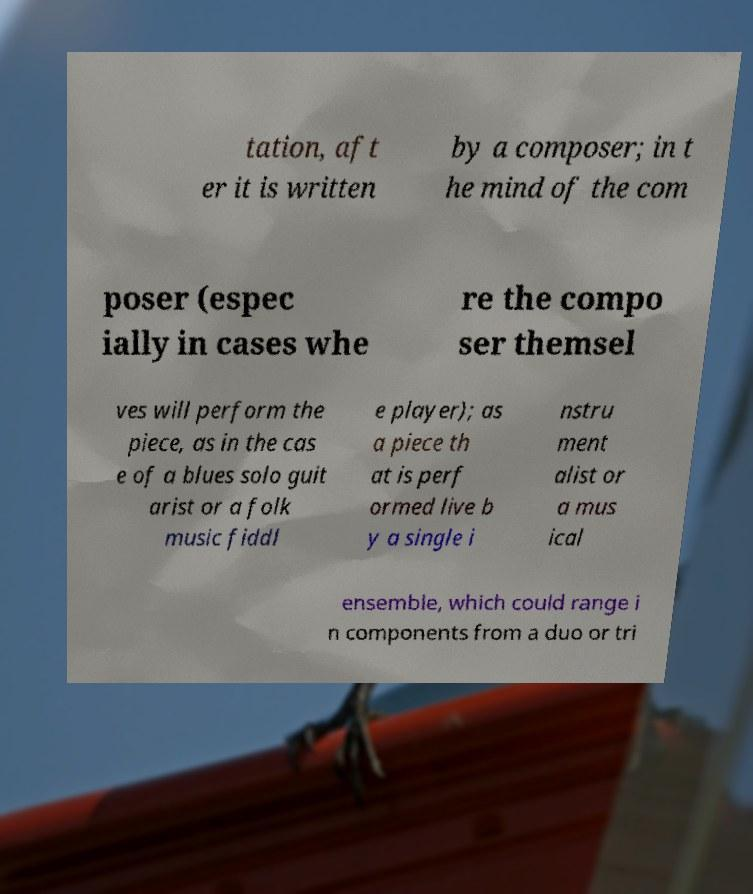For documentation purposes, I need the text within this image transcribed. Could you provide that? tation, aft er it is written by a composer; in t he mind of the com poser (espec ially in cases whe re the compo ser themsel ves will perform the piece, as in the cas e of a blues solo guit arist or a folk music fiddl e player); as a piece th at is perf ormed live b y a single i nstru ment alist or a mus ical ensemble, which could range i n components from a duo or tri 